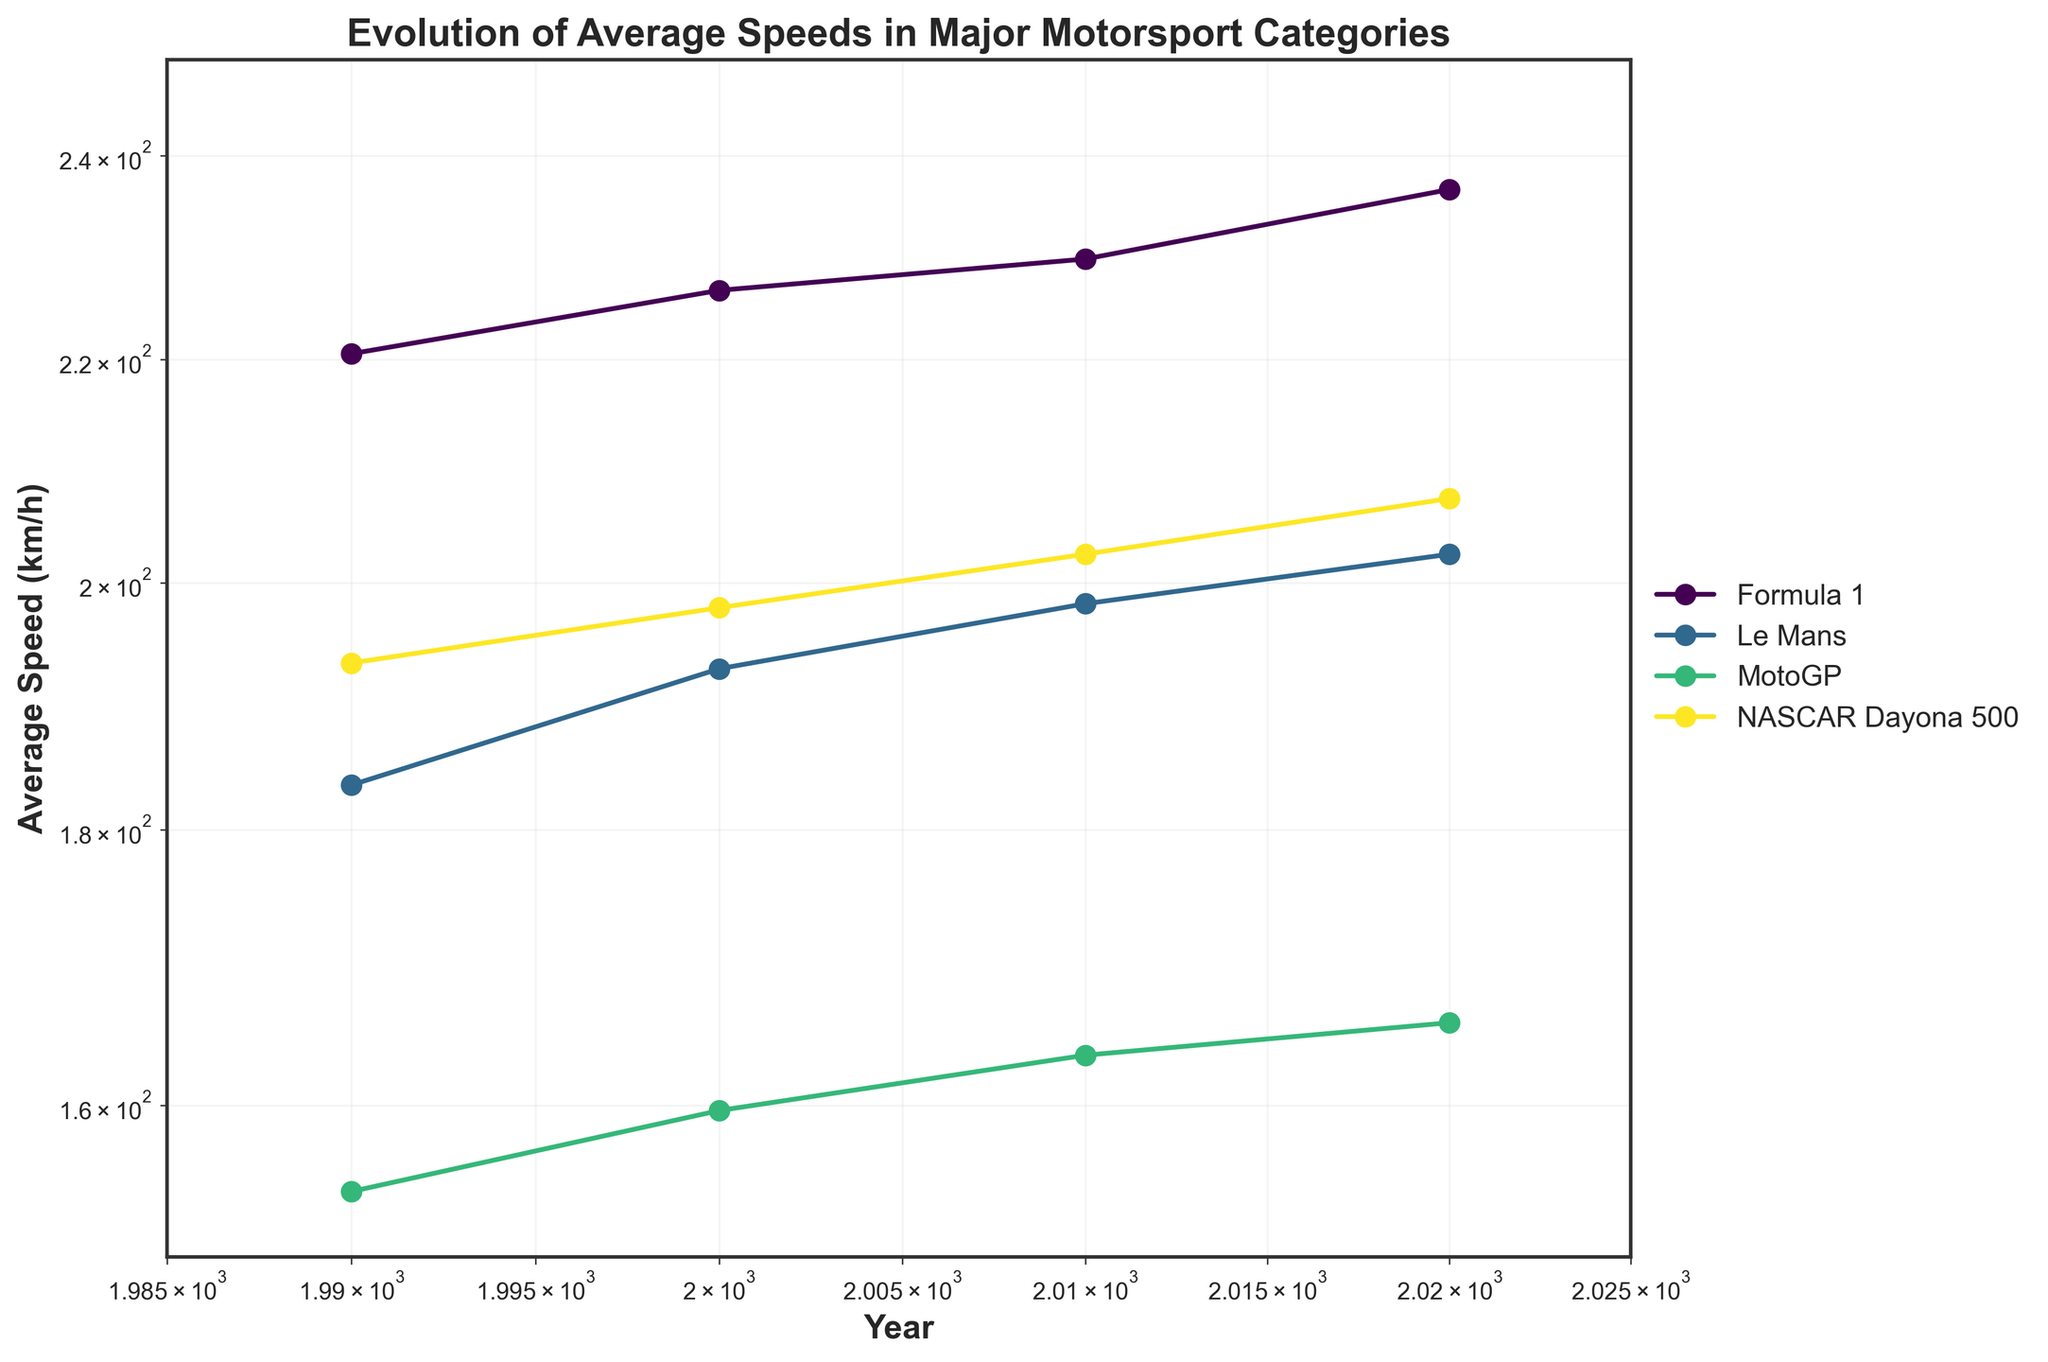what is the title of the figure? The title is displayed prominently at the top of the figure, indicating the overall subject of the plot.
Answer: Evolution of Average Speeds in Major Motorsport Categories What are the x-axis and y-axis labels? The labels for each axis provide information about the variables being plotted. The x-axis represents time, while the y-axis represents speed.
Answer: The x-axis label is "Year," and the y-axis label is "Average Speed (km/h)." Which motorsport category shows the highest average speed in 2020? By comparing the endpoints of each line for the year 2020, the category with the highest endpoint value has the highest average speed.
Answer: Formula 1 How did the average speed for MotoGP change from 1990 to 2020? By looking at the starting and ending points of the MotoGP line, we can calculate the difference in average speed over the 30-year period. The speed increased from around 154 km/h in 1990 to around 166 km/h in 2020.
Answer: Increased by about 12 km/h Which motorsport category had the least improvement in average speed from 1990 to 2020? To determine the least improvement, calculate the difference in average speed between 1990 and 2020 for each category and compare them.
Answer: NASCAR Daytona 500 How does the trend in average speeds for Le Mans compare to Formula 1? By observing the slope of the lines for Le Mans and Formula 1, we can compare the trends. Formula 1 shows a steeper slope, indicating a more significant increase in average speeds over time compared to Le Mans.
Answer: Formula 1 shows a steeper increase Which category had the most consistent improvement in average speed over the years? Consistent improvement would mean a smooth upward trend without significant fluctuations. Comparing the smoothness of the lines, Formula 1 shows the most consistent improvement.
Answer: Formula 1 Are there any overlaps in the average speeds of different categories in any year? To determine overlaps, look for points where the lines intersect or have the same y-value within a given year. There are no overlaps; each category maintains distinct average speeds throughout the years.
Answer: No What can be inferred about technological advancements in motorsport based on the plot? The overall upward trend in average speeds for all categories suggests that technological advancements have contributed to faster lap times. Formula 1 shows the most significant increase, indicating possibly the highest rate of technological adoption.
Answer: Technological advancements have led to faster speeds over time 